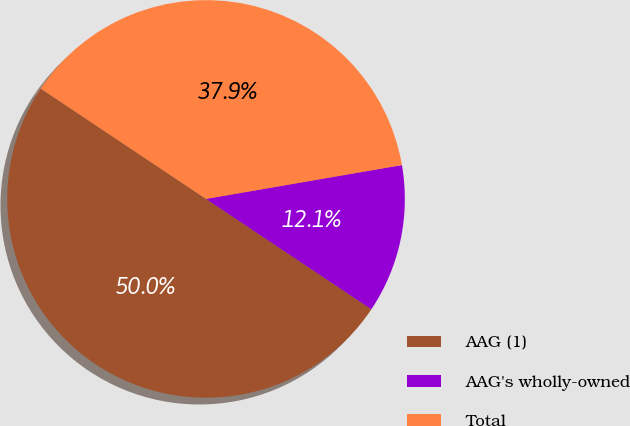Convert chart. <chart><loc_0><loc_0><loc_500><loc_500><pie_chart><fcel>AAG (1)<fcel>AAG's wholly-owned<fcel>Total<nl><fcel>50.0%<fcel>12.09%<fcel>37.91%<nl></chart> 